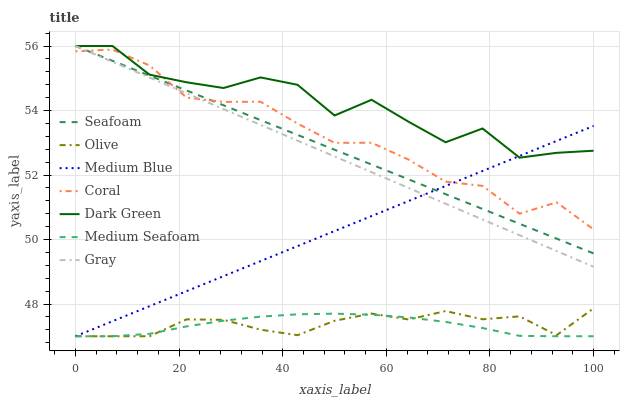Does Medium Seafoam have the minimum area under the curve?
Answer yes or no. Yes. Does Dark Green have the maximum area under the curve?
Answer yes or no. Yes. Does Coral have the minimum area under the curve?
Answer yes or no. No. Does Coral have the maximum area under the curve?
Answer yes or no. No. Is Medium Blue the smoothest?
Answer yes or no. Yes. Is Dark Green the roughest?
Answer yes or no. Yes. Is Coral the smoothest?
Answer yes or no. No. Is Coral the roughest?
Answer yes or no. No. Does Medium Blue have the lowest value?
Answer yes or no. Yes. Does Coral have the lowest value?
Answer yes or no. No. Does Dark Green have the highest value?
Answer yes or no. Yes. Does Coral have the highest value?
Answer yes or no. No. Is Olive less than Dark Green?
Answer yes or no. Yes. Is Coral greater than Medium Seafoam?
Answer yes or no. Yes. Does Gray intersect Coral?
Answer yes or no. Yes. Is Gray less than Coral?
Answer yes or no. No. Is Gray greater than Coral?
Answer yes or no. No. Does Olive intersect Dark Green?
Answer yes or no. No. 